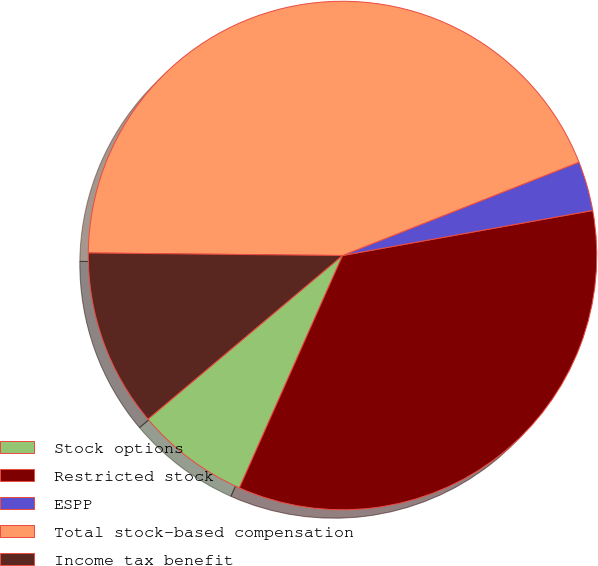<chart> <loc_0><loc_0><loc_500><loc_500><pie_chart><fcel>Stock options<fcel>Restricted stock<fcel>ESPP<fcel>Total stock-based compensation<fcel>Income tax benefit<nl><fcel>7.22%<fcel>34.48%<fcel>3.15%<fcel>43.85%<fcel>11.29%<nl></chart> 